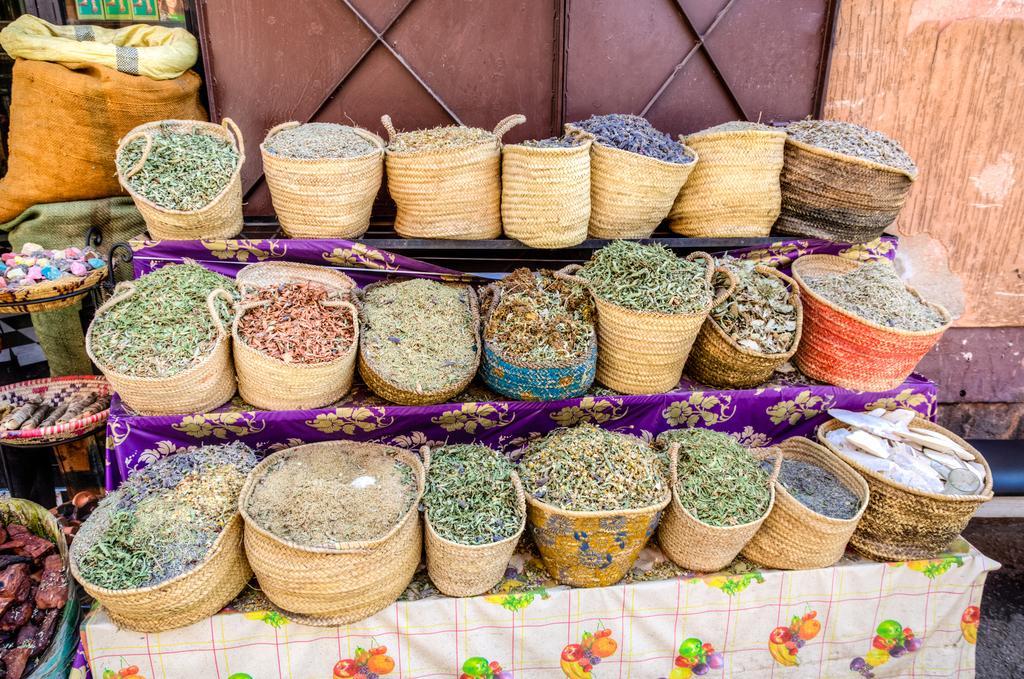In one or two sentences, can you explain what this image depicts? In this image there are tables on which there are clothes. On the table there are bags in which there are different kind of seeds and some food stuff. At the top there are metal doors. On the left side there are sac bags kept one above the other. On the right side there is a wall. 